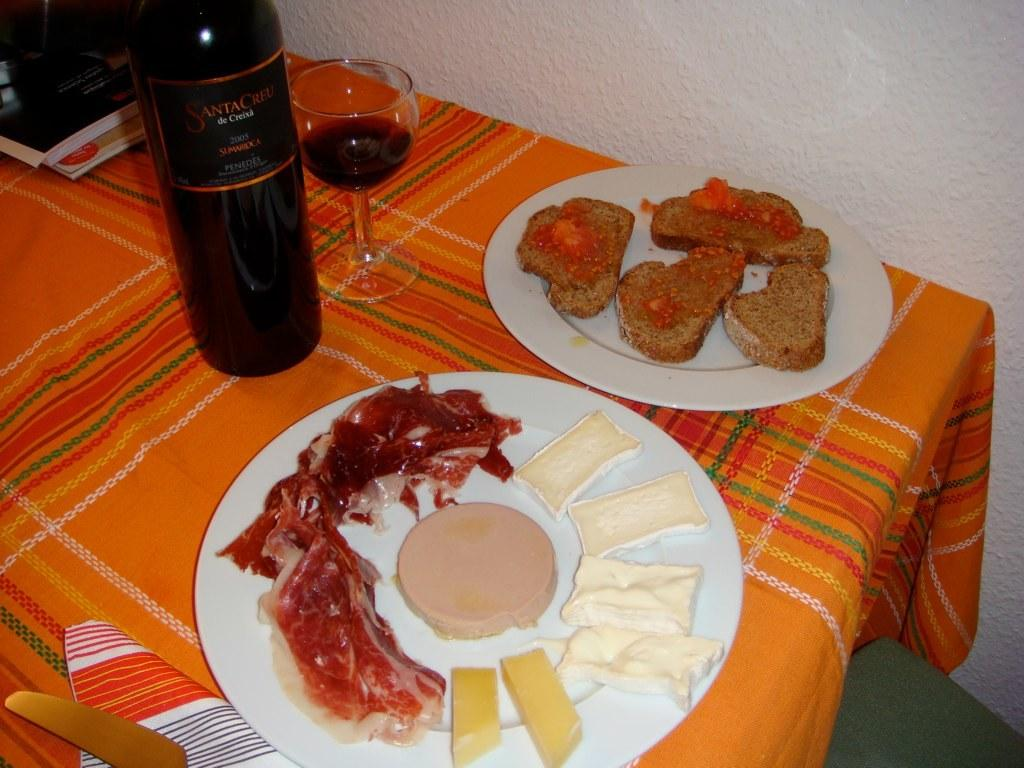<image>
Share a concise interpretation of the image provided. A bottle of 2003 red wine sits on a table next to some snacks. 